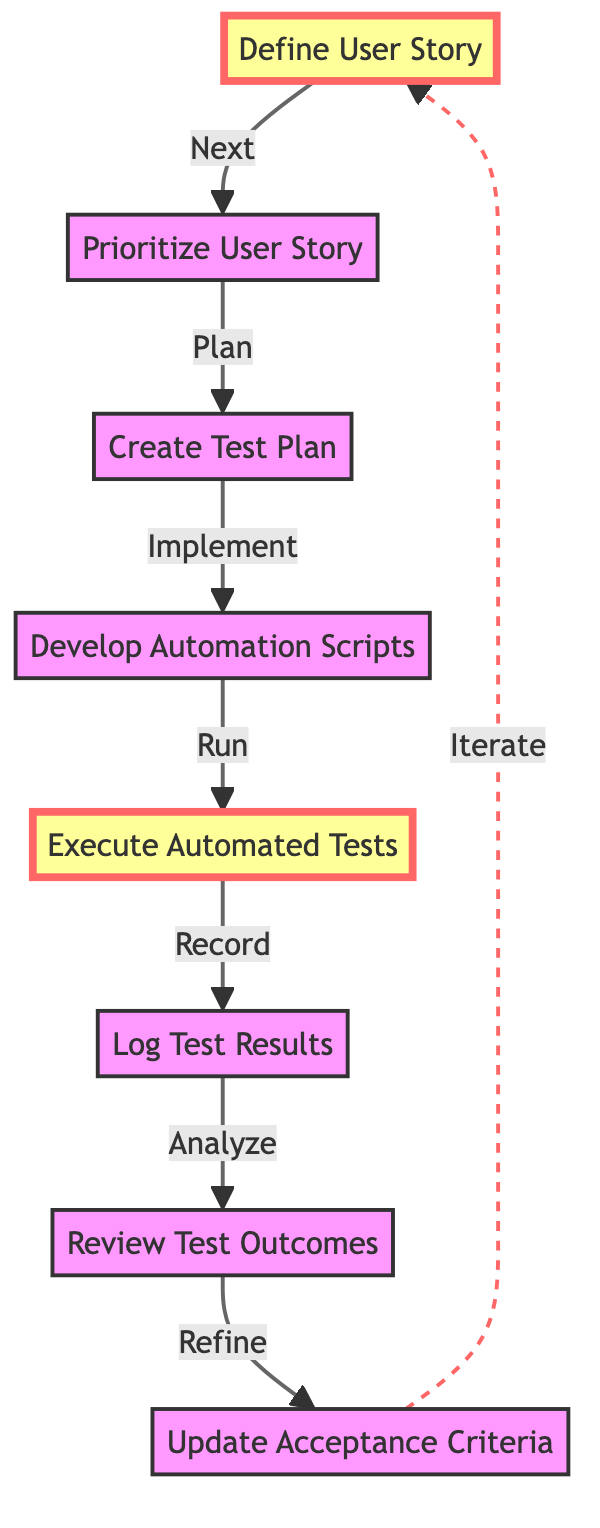What is the first step in the user story flow? The first step in the diagram is represented by the node "Define User Story," which is the starting point of the user story flow for Selenium automation testing.
Answer: Define User Story How many nodes are there in the diagram? Counting each unique action or decision in the diagram, there are eight nodes, including steps such as "Define User Story," "Prioritize User Story," and others.
Answer: Eight Which node comes after "Execute Automated Tests"? The node that follows "Execute Automated Tests" in the flow is "Log Test Results," indicating the action to be taken after executing tests.
Answer: Log Test Results What does the dashed link indicate in the diagram? The dashed link from "Update Acceptance Criteria" back to "Define User Story" indicates an iterative relationship, suggesting that the process can cycle back to refine the user story based on updates and feedback.
Answer: Iterate What is the relationship between "Develop Automation Scripts" and "Execute Automated Tests"? In the flow, "Develop Automation Scripts" leads directly to "Execute Automated Tests," as executing tests requires the scripts that were developed.
Answer: Implement What happens after "Review Test Outcomes"? After "Review Test Outcomes," the next step is to "Update Acceptance Criteria," which indicates that the review of test results leads to adjustments in the criteria for future iterations.
Answer: Update Acceptance Criteria How many edges connect the nodes in this diagram? Each directed edge represents a flow from one node to another. Upon examination of the diagram, there are seven directed edges connecting the eight nodes.
Answer: Seven What is the main purpose of the "Create Test Plan" node? The purpose of the "Create Test Plan" node is to outline the testing strategy, tools, and scope for Selenium, forming the foundation for the subsequent steps in testing automation.
Answer: Develop a test plan Which two nodes are highlighted in the diagram? The nodes that are highlighted in the diagram are "Define User Story" and "Execute Automated Tests," indicating they are significant steps in the Selenium automation testing process.
Answer: Define User Story, Execute Automated Tests 